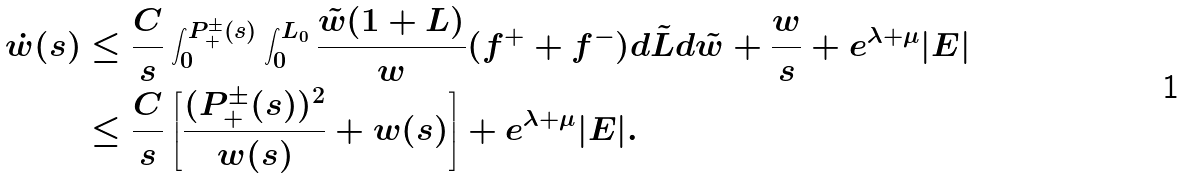Convert formula to latex. <formula><loc_0><loc_0><loc_500><loc_500>\dot { w } ( s ) & \leq \frac { C } { s } \int _ { 0 } ^ { P _ { + } ^ { \pm } ( s ) } \int _ { 0 } ^ { L _ { 0 } } \frac { \tilde { w } ( 1 + L ) } { w } ( f ^ { + } + f ^ { - } ) d \tilde { L } d \tilde { w } + \frac { w } { s } + e ^ { \lambda + \mu } | E | \\ & \leq \frac { C } { s } \left [ \frac { ( P _ { + } ^ { \pm } ( s ) ) ^ { 2 } } { w ( s ) } + w ( s ) \right ] + e ^ { \lambda + \mu } | E | .</formula> 